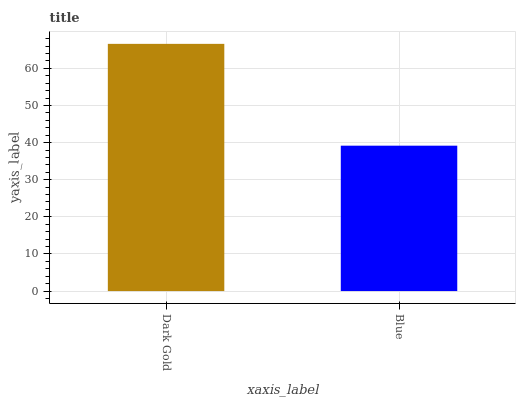Is Blue the minimum?
Answer yes or no. Yes. Is Dark Gold the maximum?
Answer yes or no. Yes. Is Blue the maximum?
Answer yes or no. No. Is Dark Gold greater than Blue?
Answer yes or no. Yes. Is Blue less than Dark Gold?
Answer yes or no. Yes. Is Blue greater than Dark Gold?
Answer yes or no. No. Is Dark Gold less than Blue?
Answer yes or no. No. Is Dark Gold the high median?
Answer yes or no. Yes. Is Blue the low median?
Answer yes or no. Yes. Is Blue the high median?
Answer yes or no. No. Is Dark Gold the low median?
Answer yes or no. No. 